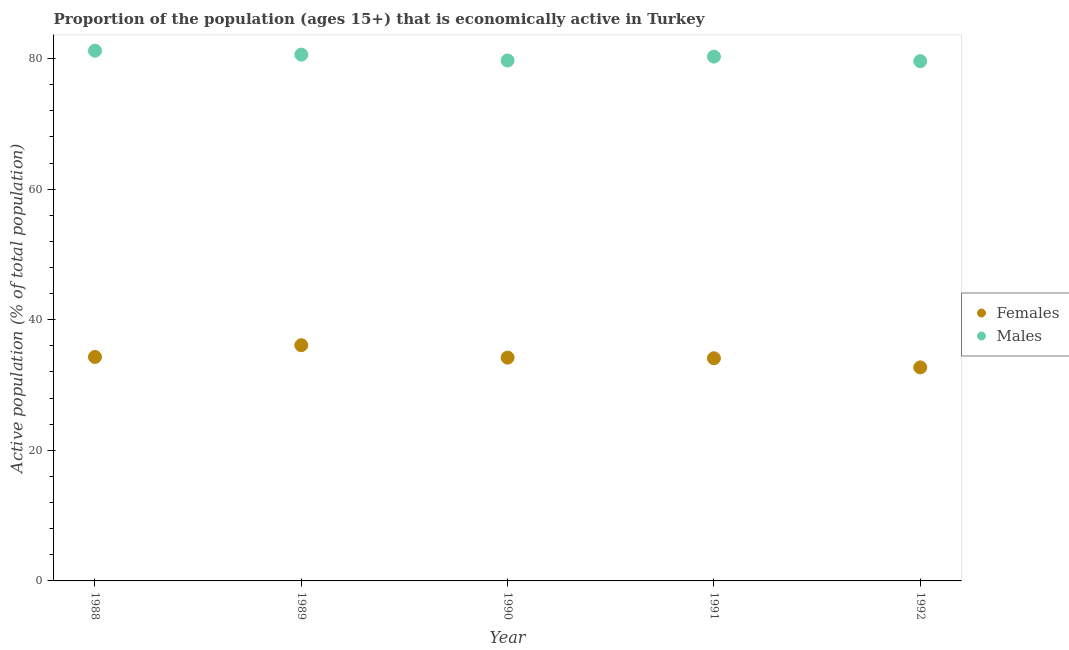How many different coloured dotlines are there?
Offer a very short reply. 2. Is the number of dotlines equal to the number of legend labels?
Your response must be concise. Yes. What is the percentage of economically active female population in 1992?
Your answer should be compact. 32.7. Across all years, what is the maximum percentage of economically active female population?
Give a very brief answer. 36.1. Across all years, what is the minimum percentage of economically active female population?
Your response must be concise. 32.7. What is the total percentage of economically active male population in the graph?
Your answer should be very brief. 401.4. What is the difference between the percentage of economically active male population in 1988 and that in 1991?
Provide a short and direct response. 0.9. What is the difference between the percentage of economically active male population in 1990 and the percentage of economically active female population in 1991?
Your response must be concise. 45.6. What is the average percentage of economically active female population per year?
Provide a short and direct response. 34.28. In the year 1991, what is the difference between the percentage of economically active female population and percentage of economically active male population?
Provide a succinct answer. -46.2. What is the ratio of the percentage of economically active female population in 1989 to that in 1990?
Your response must be concise. 1.06. What is the difference between the highest and the second highest percentage of economically active female population?
Offer a very short reply. 1.8. What is the difference between the highest and the lowest percentage of economically active male population?
Give a very brief answer. 1.6. Is the sum of the percentage of economically active male population in 1988 and 1991 greater than the maximum percentage of economically active female population across all years?
Your response must be concise. Yes. Does the percentage of economically active male population monotonically increase over the years?
Your response must be concise. No. Is the percentage of economically active female population strictly greater than the percentage of economically active male population over the years?
Keep it short and to the point. No. Is the percentage of economically active male population strictly less than the percentage of economically active female population over the years?
Your answer should be very brief. No. How many dotlines are there?
Provide a short and direct response. 2. Are the values on the major ticks of Y-axis written in scientific E-notation?
Ensure brevity in your answer.  No. Does the graph contain grids?
Give a very brief answer. No. Where does the legend appear in the graph?
Ensure brevity in your answer.  Center right. How many legend labels are there?
Provide a short and direct response. 2. What is the title of the graph?
Ensure brevity in your answer.  Proportion of the population (ages 15+) that is economically active in Turkey. Does "Male labourers" appear as one of the legend labels in the graph?
Your response must be concise. No. What is the label or title of the Y-axis?
Make the answer very short. Active population (% of total population). What is the Active population (% of total population) of Females in 1988?
Your answer should be compact. 34.3. What is the Active population (% of total population) of Males in 1988?
Offer a terse response. 81.2. What is the Active population (% of total population) of Females in 1989?
Make the answer very short. 36.1. What is the Active population (% of total population) in Males in 1989?
Provide a short and direct response. 80.6. What is the Active population (% of total population) of Females in 1990?
Provide a succinct answer. 34.2. What is the Active population (% of total population) in Males in 1990?
Offer a very short reply. 79.7. What is the Active population (% of total population) of Females in 1991?
Give a very brief answer. 34.1. What is the Active population (% of total population) in Males in 1991?
Offer a very short reply. 80.3. What is the Active population (% of total population) of Females in 1992?
Provide a succinct answer. 32.7. What is the Active population (% of total population) in Males in 1992?
Give a very brief answer. 79.6. Across all years, what is the maximum Active population (% of total population) of Females?
Offer a very short reply. 36.1. Across all years, what is the maximum Active population (% of total population) of Males?
Provide a succinct answer. 81.2. Across all years, what is the minimum Active population (% of total population) in Females?
Keep it short and to the point. 32.7. Across all years, what is the minimum Active population (% of total population) in Males?
Provide a short and direct response. 79.6. What is the total Active population (% of total population) in Females in the graph?
Your answer should be compact. 171.4. What is the total Active population (% of total population) of Males in the graph?
Make the answer very short. 401.4. What is the difference between the Active population (% of total population) of Females in 1988 and that in 1990?
Offer a terse response. 0.1. What is the difference between the Active population (% of total population) in Males in 1988 and that in 1990?
Offer a very short reply. 1.5. What is the difference between the Active population (% of total population) in Females in 1988 and that in 1992?
Ensure brevity in your answer.  1.6. What is the difference between the Active population (% of total population) of Males in 1988 and that in 1992?
Your answer should be very brief. 1.6. What is the difference between the Active population (% of total population) of Males in 1989 and that in 1991?
Your answer should be compact. 0.3. What is the difference between the Active population (% of total population) of Females in 1990 and that in 1991?
Make the answer very short. 0.1. What is the difference between the Active population (% of total population) of Females in 1990 and that in 1992?
Offer a terse response. 1.5. What is the difference between the Active population (% of total population) of Males in 1991 and that in 1992?
Give a very brief answer. 0.7. What is the difference between the Active population (% of total population) in Females in 1988 and the Active population (% of total population) in Males in 1989?
Keep it short and to the point. -46.3. What is the difference between the Active population (% of total population) of Females in 1988 and the Active population (% of total population) of Males in 1990?
Offer a very short reply. -45.4. What is the difference between the Active population (% of total population) of Females in 1988 and the Active population (% of total population) of Males in 1991?
Ensure brevity in your answer.  -46. What is the difference between the Active population (% of total population) in Females in 1988 and the Active population (% of total population) in Males in 1992?
Provide a short and direct response. -45.3. What is the difference between the Active population (% of total population) in Females in 1989 and the Active population (% of total population) in Males in 1990?
Offer a very short reply. -43.6. What is the difference between the Active population (% of total population) of Females in 1989 and the Active population (% of total population) of Males in 1991?
Provide a short and direct response. -44.2. What is the difference between the Active population (% of total population) in Females in 1989 and the Active population (% of total population) in Males in 1992?
Keep it short and to the point. -43.5. What is the difference between the Active population (% of total population) of Females in 1990 and the Active population (% of total population) of Males in 1991?
Make the answer very short. -46.1. What is the difference between the Active population (% of total population) in Females in 1990 and the Active population (% of total population) in Males in 1992?
Make the answer very short. -45.4. What is the difference between the Active population (% of total population) in Females in 1991 and the Active population (% of total population) in Males in 1992?
Your answer should be very brief. -45.5. What is the average Active population (% of total population) in Females per year?
Ensure brevity in your answer.  34.28. What is the average Active population (% of total population) in Males per year?
Provide a short and direct response. 80.28. In the year 1988, what is the difference between the Active population (% of total population) of Females and Active population (% of total population) of Males?
Your response must be concise. -46.9. In the year 1989, what is the difference between the Active population (% of total population) in Females and Active population (% of total population) in Males?
Your answer should be very brief. -44.5. In the year 1990, what is the difference between the Active population (% of total population) in Females and Active population (% of total population) in Males?
Offer a very short reply. -45.5. In the year 1991, what is the difference between the Active population (% of total population) in Females and Active population (% of total population) in Males?
Your response must be concise. -46.2. In the year 1992, what is the difference between the Active population (% of total population) in Females and Active population (% of total population) in Males?
Your response must be concise. -46.9. What is the ratio of the Active population (% of total population) in Females in 1988 to that in 1989?
Give a very brief answer. 0.95. What is the ratio of the Active population (% of total population) of Males in 1988 to that in 1989?
Your answer should be compact. 1.01. What is the ratio of the Active population (% of total population) of Females in 1988 to that in 1990?
Make the answer very short. 1. What is the ratio of the Active population (% of total population) in Males in 1988 to that in 1990?
Provide a short and direct response. 1.02. What is the ratio of the Active population (% of total population) in Females in 1988 to that in 1991?
Provide a short and direct response. 1.01. What is the ratio of the Active population (% of total population) of Males in 1988 to that in 1991?
Give a very brief answer. 1.01. What is the ratio of the Active population (% of total population) of Females in 1988 to that in 1992?
Give a very brief answer. 1.05. What is the ratio of the Active population (% of total population) in Males in 1988 to that in 1992?
Give a very brief answer. 1.02. What is the ratio of the Active population (% of total population) in Females in 1989 to that in 1990?
Keep it short and to the point. 1.06. What is the ratio of the Active population (% of total population) in Males in 1989 to that in 1990?
Make the answer very short. 1.01. What is the ratio of the Active population (% of total population) of Females in 1989 to that in 1991?
Provide a short and direct response. 1.06. What is the ratio of the Active population (% of total population) of Males in 1989 to that in 1991?
Your response must be concise. 1. What is the ratio of the Active population (% of total population) in Females in 1989 to that in 1992?
Offer a terse response. 1.1. What is the ratio of the Active population (% of total population) of Males in 1989 to that in 1992?
Keep it short and to the point. 1.01. What is the ratio of the Active population (% of total population) in Males in 1990 to that in 1991?
Keep it short and to the point. 0.99. What is the ratio of the Active population (% of total population) of Females in 1990 to that in 1992?
Offer a terse response. 1.05. What is the ratio of the Active population (% of total population) of Females in 1991 to that in 1992?
Ensure brevity in your answer.  1.04. What is the ratio of the Active population (% of total population) in Males in 1991 to that in 1992?
Give a very brief answer. 1.01. What is the difference between the highest and the lowest Active population (% of total population) in Females?
Keep it short and to the point. 3.4. What is the difference between the highest and the lowest Active population (% of total population) of Males?
Offer a terse response. 1.6. 